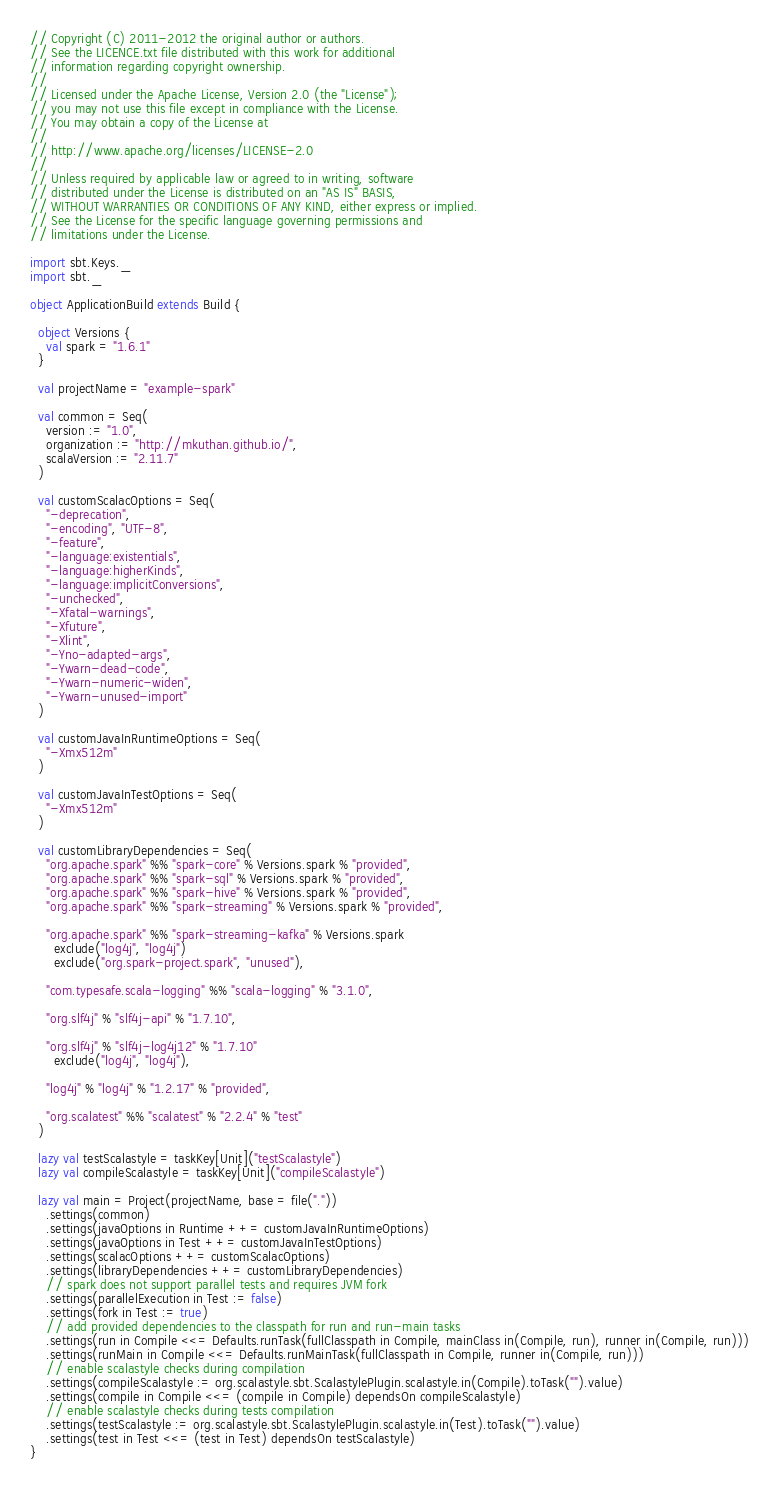<code> <loc_0><loc_0><loc_500><loc_500><_Scala_>// Copyright (C) 2011-2012 the original author or authors.
// See the LICENCE.txt file distributed with this work for additional
// information regarding copyright ownership.
//
// Licensed under the Apache License, Version 2.0 (the "License");
// you may not use this file except in compliance with the License.
// You may obtain a copy of the License at
//
// http://www.apache.org/licenses/LICENSE-2.0
//
// Unless required by applicable law or agreed to in writing, software
// distributed under the License is distributed on an "AS IS" BASIS,
// WITHOUT WARRANTIES OR CONDITIONS OF ANY KIND, either express or implied.
// See the License for the specific language governing permissions and
// limitations under the License.

import sbt.Keys._
import sbt._

object ApplicationBuild extends Build {

  object Versions {
    val spark = "1.6.1"
  }

  val projectName = "example-spark"

  val common = Seq(
    version := "1.0",
    organization := "http://mkuthan.github.io/",
    scalaVersion := "2.11.7"
  )

  val customScalacOptions = Seq(
    "-deprecation",
    "-encoding", "UTF-8",
    "-feature",
    "-language:existentials",
    "-language:higherKinds",
    "-language:implicitConversions",
    "-unchecked",
    "-Xfatal-warnings",
    "-Xfuture",
    "-Xlint",
    "-Yno-adapted-args",
    "-Ywarn-dead-code",
    "-Ywarn-numeric-widen",
    "-Ywarn-unused-import"
  )

  val customJavaInRuntimeOptions = Seq(
    "-Xmx512m"
  )

  val customJavaInTestOptions = Seq(
    "-Xmx512m"
  )

  val customLibraryDependencies = Seq(
    "org.apache.spark" %% "spark-core" % Versions.spark % "provided",
    "org.apache.spark" %% "spark-sql" % Versions.spark % "provided",
    "org.apache.spark" %% "spark-hive" % Versions.spark % "provided",
    "org.apache.spark" %% "spark-streaming" % Versions.spark % "provided",

    "org.apache.spark" %% "spark-streaming-kafka" % Versions.spark
      exclude("log4j", "log4j")
      exclude("org.spark-project.spark", "unused"),

    "com.typesafe.scala-logging" %% "scala-logging" % "3.1.0",

    "org.slf4j" % "slf4j-api" % "1.7.10",

    "org.slf4j" % "slf4j-log4j12" % "1.7.10"
      exclude("log4j", "log4j"),

    "log4j" % "log4j" % "1.2.17" % "provided",

    "org.scalatest" %% "scalatest" % "2.2.4" % "test"
  )

  lazy val testScalastyle = taskKey[Unit]("testScalastyle")
  lazy val compileScalastyle = taskKey[Unit]("compileScalastyle")

  lazy val main = Project(projectName, base = file("."))
    .settings(common)
    .settings(javaOptions in Runtime ++= customJavaInRuntimeOptions)
    .settings(javaOptions in Test ++= customJavaInTestOptions)
    .settings(scalacOptions ++= customScalacOptions)
    .settings(libraryDependencies ++= customLibraryDependencies)
    // spark does not support parallel tests and requires JVM fork
    .settings(parallelExecution in Test := false)
    .settings(fork in Test := true)
    // add provided dependencies to the classpath for run and run-main tasks
    .settings(run in Compile <<= Defaults.runTask(fullClasspath in Compile, mainClass in(Compile, run), runner in(Compile, run)))
    .settings(runMain in Compile <<= Defaults.runMainTask(fullClasspath in Compile, runner in(Compile, run)))
    // enable scalastyle checks during compilation
    .settings(compileScalastyle := org.scalastyle.sbt.ScalastylePlugin.scalastyle.in(Compile).toTask("").value)
    .settings(compile in Compile <<= (compile in Compile) dependsOn compileScalastyle)
    // enable scalastyle checks during tests compilation
    .settings(testScalastyle := org.scalastyle.sbt.ScalastylePlugin.scalastyle.in(Test).toTask("").value)
    .settings(test in Test <<= (test in Test) dependsOn testScalastyle)
}

</code> 